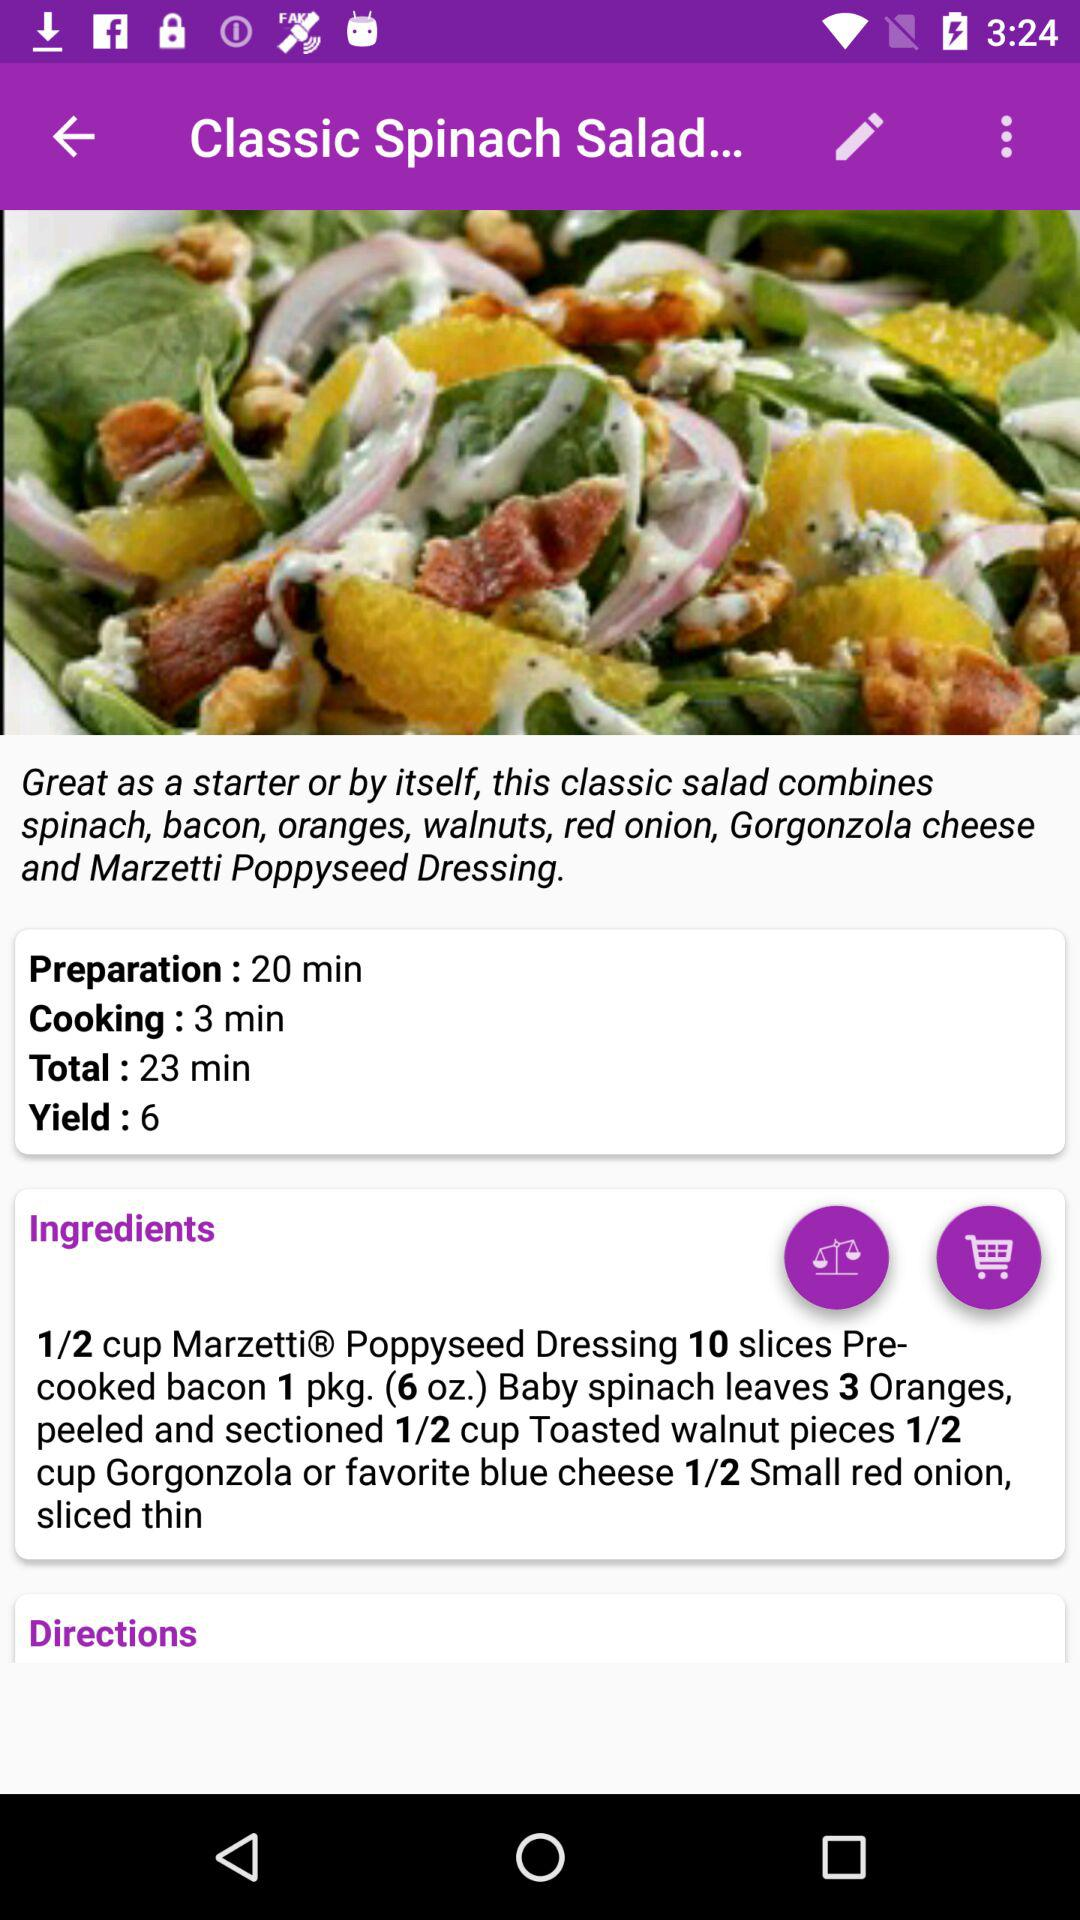What is the cooking time of the dish? The cooking time is 3 minutes. 